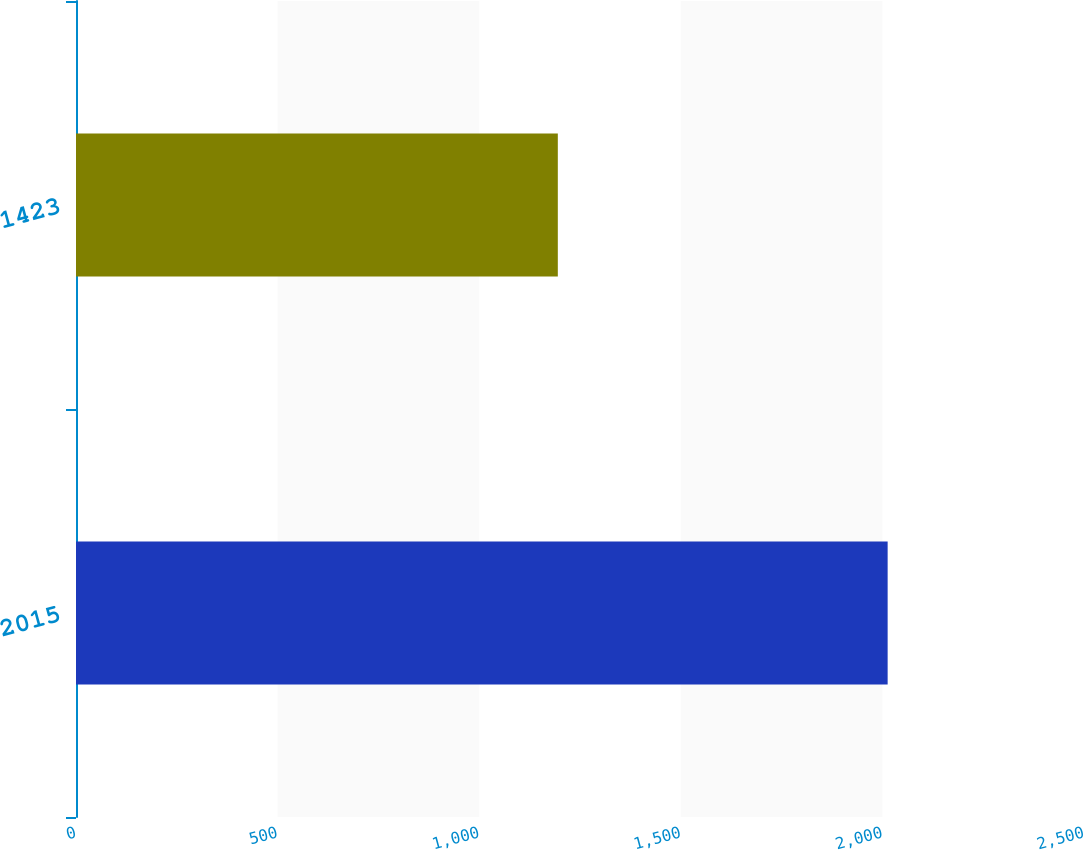Convert chart to OTSL. <chart><loc_0><loc_0><loc_500><loc_500><bar_chart><fcel>2015<fcel>1423<nl><fcel>2013<fcel>1195<nl></chart> 